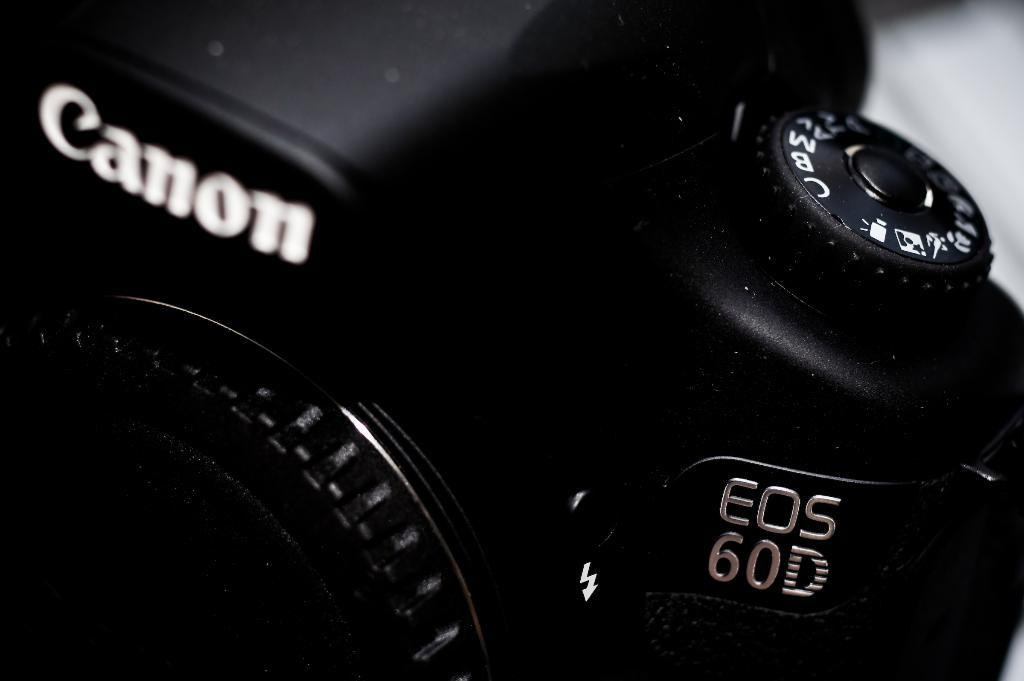What object is the main focus of the image? There is a camera in the image. What can be said about the color of the camera? The camera is black in color. How many stars are visible on the camera in the image? There are no stars visible on the camera in the image. What type of slip is being used to hold the camera in the image? There is no slip present in the image; the camera is not being held by any object. 